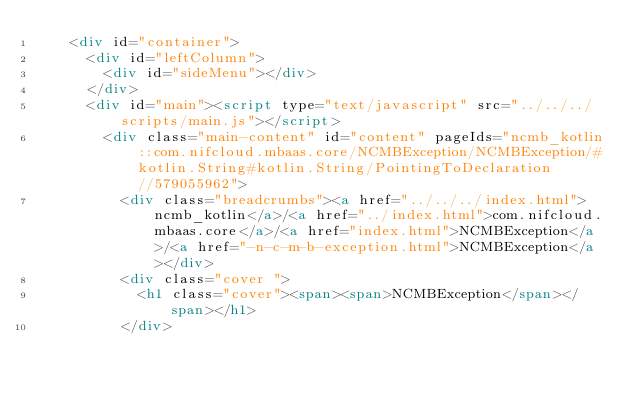Convert code to text. <code><loc_0><loc_0><loc_500><loc_500><_HTML_>    <div id="container">
      <div id="leftColumn">
        <div id="sideMenu"></div>
      </div>
      <div id="main"><script type="text/javascript" src="../../../scripts/main.js"></script>
        <div class="main-content" id="content" pageIds="ncmb_kotlin::com.nifcloud.mbaas.core/NCMBException/NCMBException/#kotlin.String#kotlin.String/PointingToDeclaration//579055962">
          <div class="breadcrumbs"><a href="../../../index.html">ncmb_kotlin</a>/<a href="../index.html">com.nifcloud.mbaas.core</a>/<a href="index.html">NCMBException</a>/<a href="-n-c-m-b-exception.html">NCMBException</a></div>
          <div class="cover ">
            <h1 class="cover"><span><span>NCMBException</span></span></h1>
          </div></code> 